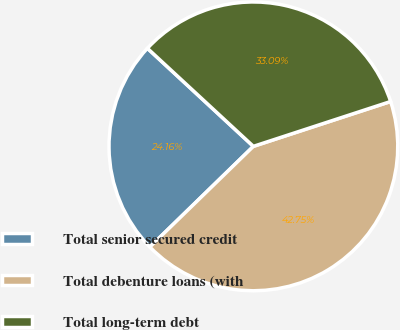<chart> <loc_0><loc_0><loc_500><loc_500><pie_chart><fcel>Total senior secured credit<fcel>Total debenture loans (with<fcel>Total long-term debt<nl><fcel>24.16%<fcel>42.75%<fcel>33.09%<nl></chart> 